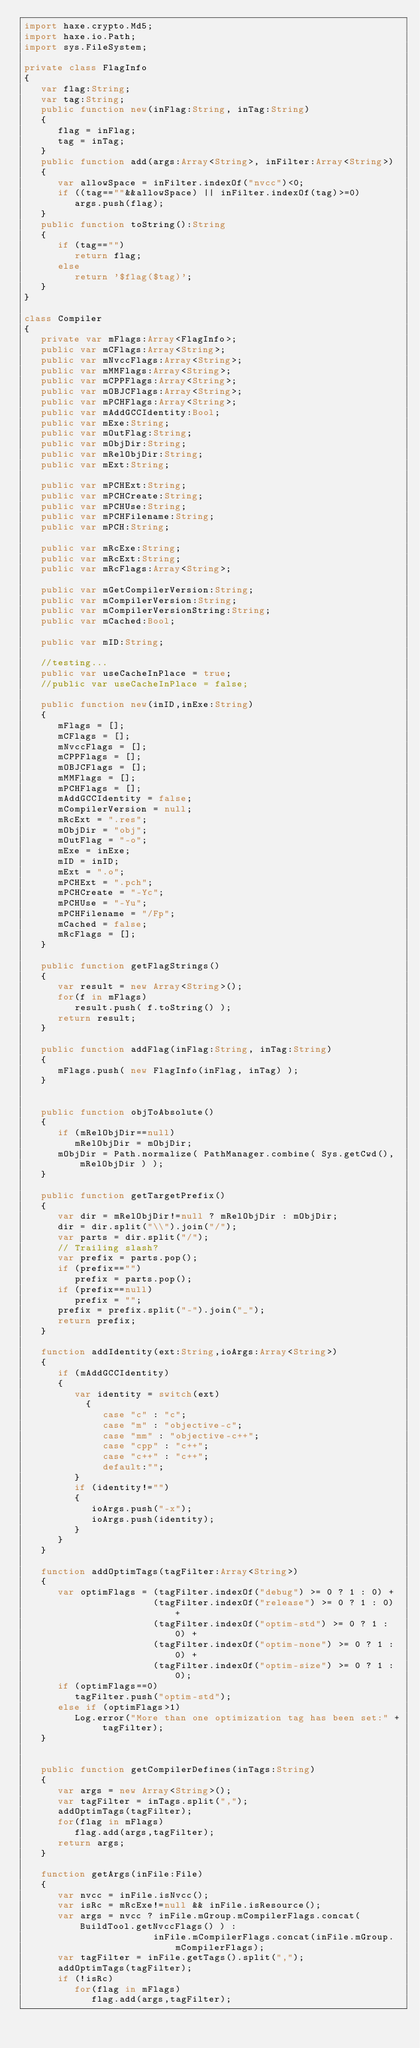<code> <loc_0><loc_0><loc_500><loc_500><_Haxe_>import haxe.crypto.Md5;
import haxe.io.Path;
import sys.FileSystem;

private class FlagInfo
{
   var flag:String;
   var tag:String;
   public function new(inFlag:String, inTag:String)
   {
      flag = inFlag;
      tag = inTag;
   }
   public function add(args:Array<String>, inFilter:Array<String>)
   {
      var allowSpace = inFilter.indexOf("nvcc")<0;
      if ((tag==""&&allowSpace) || inFilter.indexOf(tag)>=0)
         args.push(flag);
   }
   public function toString():String
   {
      if (tag=="")
         return flag;
      else
         return '$flag($tag)';
   }
}

class Compiler
{
   private var mFlags:Array<FlagInfo>;
   public var mCFlags:Array<String>;
   public var mNvccFlags:Array<String>;
   public var mMMFlags:Array<String>;
   public var mCPPFlags:Array<String>;
   public var mOBJCFlags:Array<String>;
   public var mPCHFlags:Array<String>;
   public var mAddGCCIdentity:Bool;
   public var mExe:String;
   public var mOutFlag:String;
   public var mObjDir:String;
   public var mRelObjDir:String;
   public var mExt:String;

   public var mPCHExt:String;
   public var mPCHCreate:String;
   public var mPCHUse:String;
   public var mPCHFilename:String;
   public var mPCH:String;

   public var mRcExe:String;
   public var mRcExt:String;
   public var mRcFlags:Array<String>;

   public var mGetCompilerVersion:String;
   public var mCompilerVersion:String;
   public var mCompilerVersionString:String;
   public var mCached:Bool;

   public var mID:String;

   //testing...
   public var useCacheInPlace = true;
   //public var useCacheInPlace = false;

   public function new(inID,inExe:String)
   {
      mFlags = [];
      mCFlags = [];
      mNvccFlags = [];
      mCPPFlags = [];
      mOBJCFlags = [];
      mMMFlags = [];
      mPCHFlags = [];
      mAddGCCIdentity = false;
      mCompilerVersion = null;
      mRcExt = ".res";
      mObjDir = "obj";
      mOutFlag = "-o";
      mExe = inExe;
      mID = inID;
      mExt = ".o";
      mPCHExt = ".pch";
      mPCHCreate = "-Yc";
      mPCHUse = "-Yu";
      mPCHFilename = "/Fp";
      mCached = false;
      mRcFlags = [];
   }

   public function getFlagStrings()
   {
      var result = new Array<String>();
      for(f in mFlags)
         result.push( f.toString() );
      return result;
   }

   public function addFlag(inFlag:String, inTag:String)
   {
      mFlags.push( new FlagInfo(inFlag, inTag) );
   }


   public function objToAbsolute()
   {
      if (mRelObjDir==null)
         mRelObjDir = mObjDir;
      mObjDir = Path.normalize( PathManager.combine( Sys.getCwd(), mRelObjDir ) );
   }

   public function getTargetPrefix()
   {
      var dir = mRelObjDir!=null ? mRelObjDir : mObjDir;
      dir = dir.split("\\").join("/");
      var parts = dir.split("/");
      // Trailing slash?
      var prefix = parts.pop();
      if (prefix=="")
         prefix = parts.pop();
      if (prefix==null)
         prefix = "";
      prefix = prefix.split("-").join("_");
      return prefix;
   }

   function addIdentity(ext:String,ioArgs:Array<String>)
   {
      if (mAddGCCIdentity)
      {
         var identity = switch(ext)
           {
              case "c" : "c";
              case "m" : "objective-c";
              case "mm" : "objective-c++";
              case "cpp" : "c++";
              case "c++" : "c++";
              default:"";
         }
         if (identity!="")
         {
            ioArgs.push("-x");
            ioArgs.push(identity);
         }
      }
   }

   function addOptimTags(tagFilter:Array<String>)
   {
      var optimFlags = (tagFilter.indexOf("debug") >= 0 ? 1 : 0) +
                       (tagFilter.indexOf("release") >= 0 ? 1 : 0) +
                       (tagFilter.indexOf("optim-std") >= 0 ? 1 : 0) +
                       (tagFilter.indexOf("optim-none") >= 0 ? 1 : 0) +
                       (tagFilter.indexOf("optim-size") >= 0 ? 1 : 0);
      if (optimFlags==0)
         tagFilter.push("optim-std");
      else if (optimFlags>1)
         Log.error("More than one optimization tag has been set:" + tagFilter);
   }


   public function getCompilerDefines(inTags:String)
   {
      var args = new Array<String>();
      var tagFilter = inTags.split(",");
      addOptimTags(tagFilter);
      for(flag in mFlags)
         flag.add(args,tagFilter);
      return args;
   }

   function getArgs(inFile:File)
   {
      var nvcc = inFile.isNvcc();
      var isRc = mRcExe!=null && inFile.isResource();
      var args = nvcc ? inFile.mGroup.mCompilerFlags.concat( BuildTool.getNvccFlags() ) :
                       inFile.mCompilerFlags.concat(inFile.mGroup.mCompilerFlags);
      var tagFilter = inFile.getTags().split(",");
      addOptimTags(tagFilter);
      if (!isRc)
         for(flag in mFlags)
            flag.add(args,tagFilter);</code> 